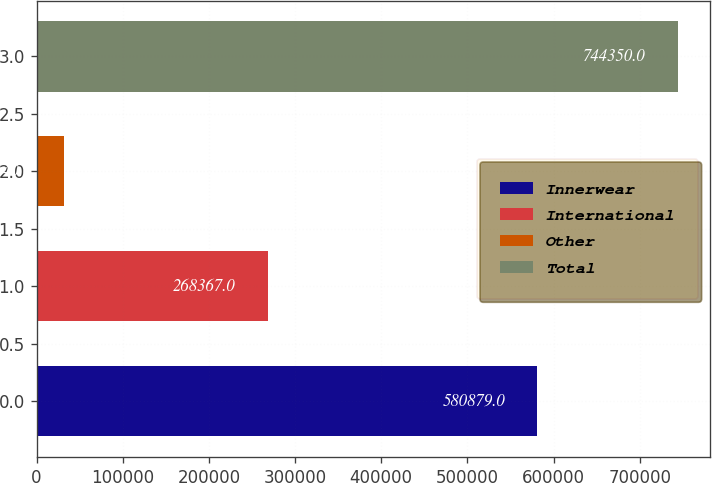Convert chart to OTSL. <chart><loc_0><loc_0><loc_500><loc_500><bar_chart><fcel>Innerwear<fcel>International<fcel>Other<fcel>Total<nl><fcel>580879<fcel>268367<fcel>31540<fcel>744350<nl></chart> 